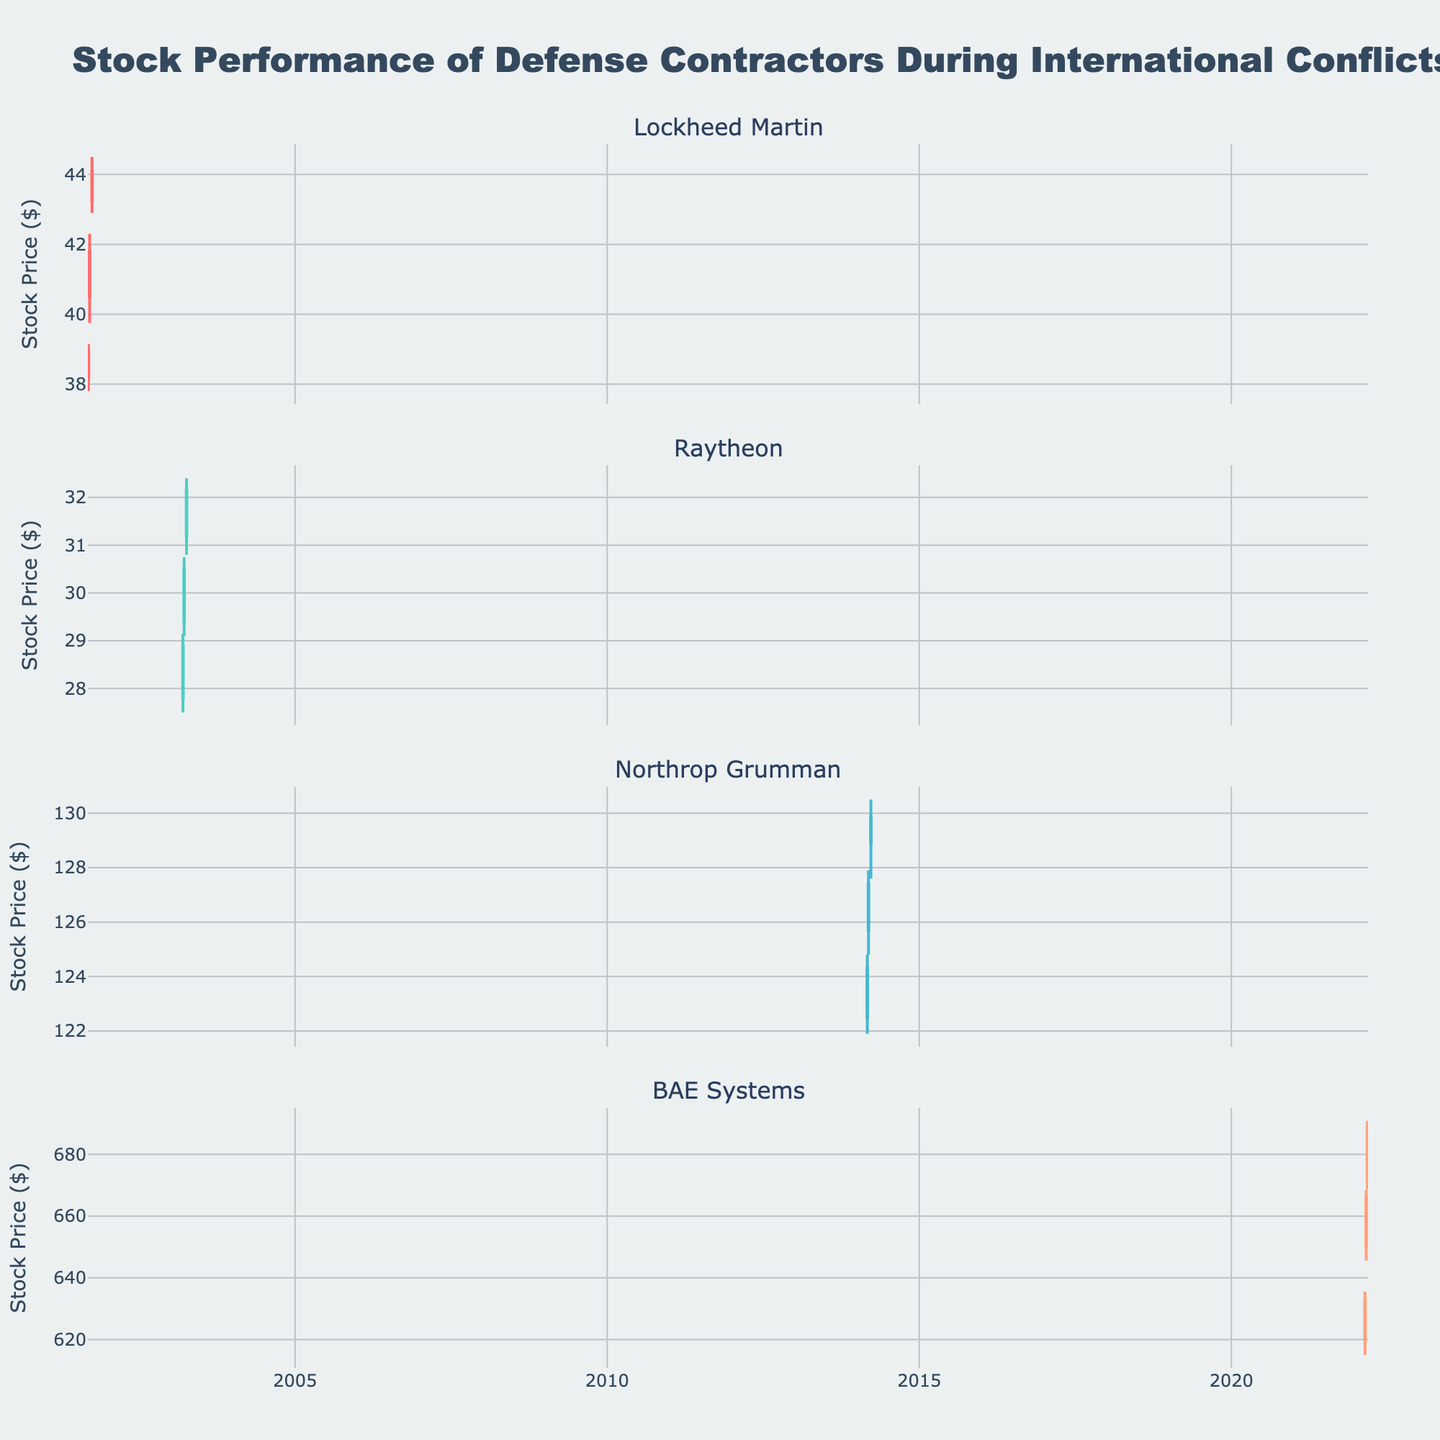What is the title of the figure? The title of the figure is located at the top and is usually in a larger font size than other text elements.
Answer: Stock Performance of Defense Contractors During International Conflicts How many companies are plotted in the figure? The figure is divided into subplots, each representing a different company. Count the number of distinct subplots.
Answer: 4 Which company had the highest closing price and what was that price? Look at the highest "Close" value across all subplots. The highest closing price can be found by comparing the ending prices in each subplot.
Answer: Northrop Grumman, $129.80 Between 2001-09-10 and 2001-09-17, by how much did Lockheed Martin's closing price increase? Subtract the closing price of Lockheed Martin on 2001-09-10 from the closing price on 2001-09-17.
Answer: $2.85 During the given period in 2022, did BAE Systems consistently show an increasing stock trend? Examine the closing prices of BAE Systems across the dates in 2022 and see if each subsequent closing price is higher than the previous one.
Answer: Yes On 2003-03-24, what is the range of Raytheon's stock price? The range is determined by subtracting the lowest price (Low) from the highest price (High) on that date.
Answer: $1.65 Which company showed the largest increase in closing price over a single time period? Compare the differences in closing prices for each company between the different dates. Look for the largest positive change.
Answer: BAE Systems, $22.40 What can be inferred about Northrop Grumman's stock activity in March 2014? Look at the overall trend and pattern of Northrop Grumman's stock prices over the given dates to infer its stock activity.
Answer: Consistently increasing Which time period did Raytheon demonstrate the maximum volatility, and what evidence supports this? Volatility can be inferred from the range between the high and low prices. Examine the date range with the largest gap between high and low.
Answer: 2003-04-07, from $31.20 to $32.40 What color represents increasing stock prices for Lockheed Martin? Identify the color used in the plot for the increasing prices of Lockheed Martin. The subplot title Lockheed Martin will help locate it visually.
Answer: #FF6B6B 